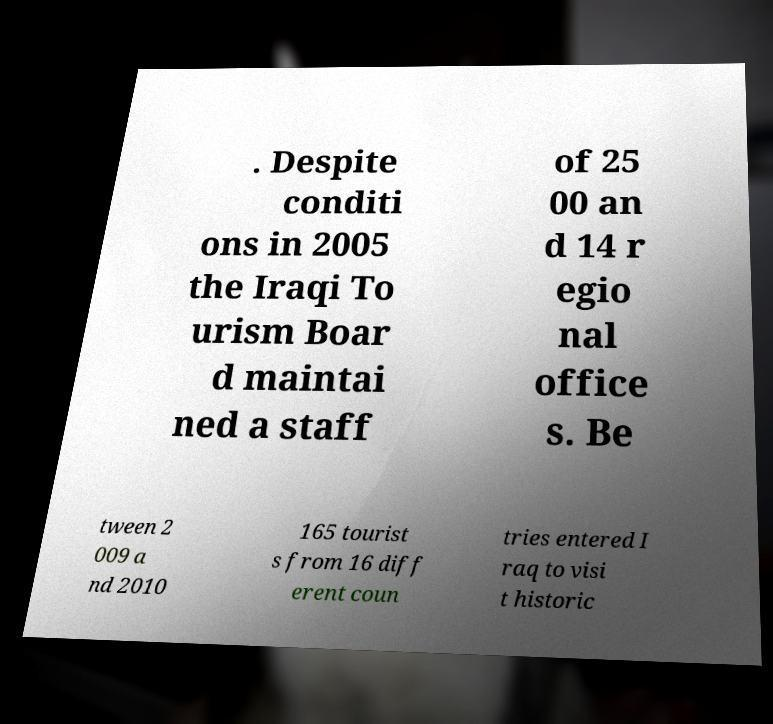Please identify and transcribe the text found in this image. . Despite conditi ons in 2005 the Iraqi To urism Boar d maintai ned a staff of 25 00 an d 14 r egio nal office s. Be tween 2 009 a nd 2010 165 tourist s from 16 diff erent coun tries entered I raq to visi t historic 